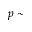<formula> <loc_0><loc_0><loc_500><loc_500>p \sim</formula> 